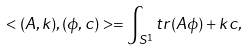<formula> <loc_0><loc_0><loc_500><loc_500>< ( A , k ) , ( \phi , c ) > = \int _ { S ^ { 1 } } t r ( A \phi ) + k c ,</formula> 